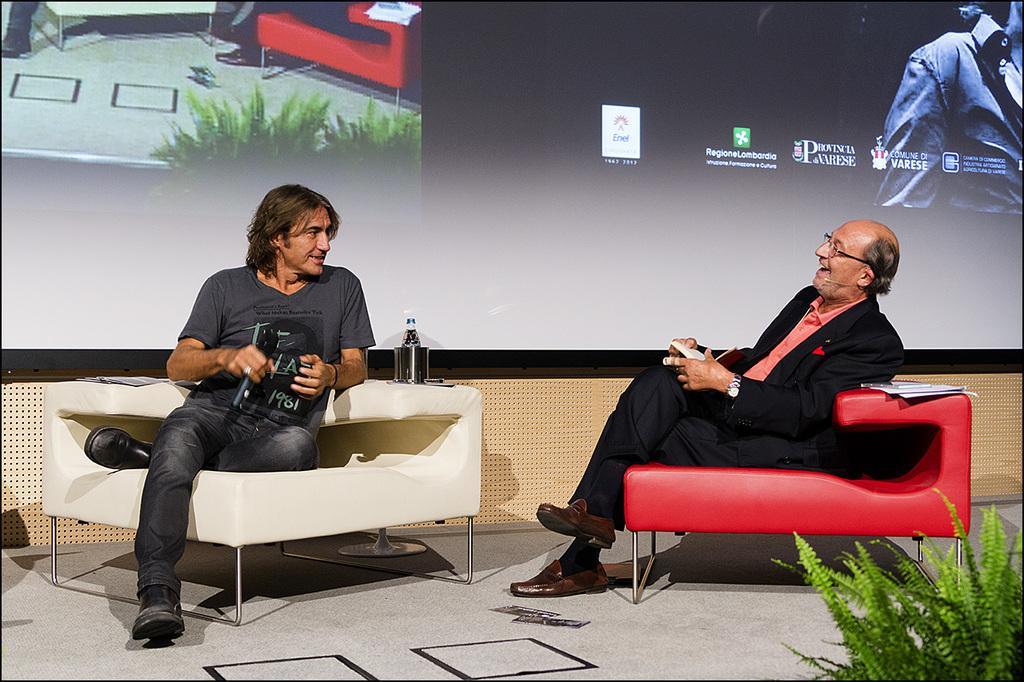Please provide a concise description of this image. In this image there are two persons sitting on the chairs and they are holding an object in their hand, there are few objects placed on the chair. In the background there is a screen. 